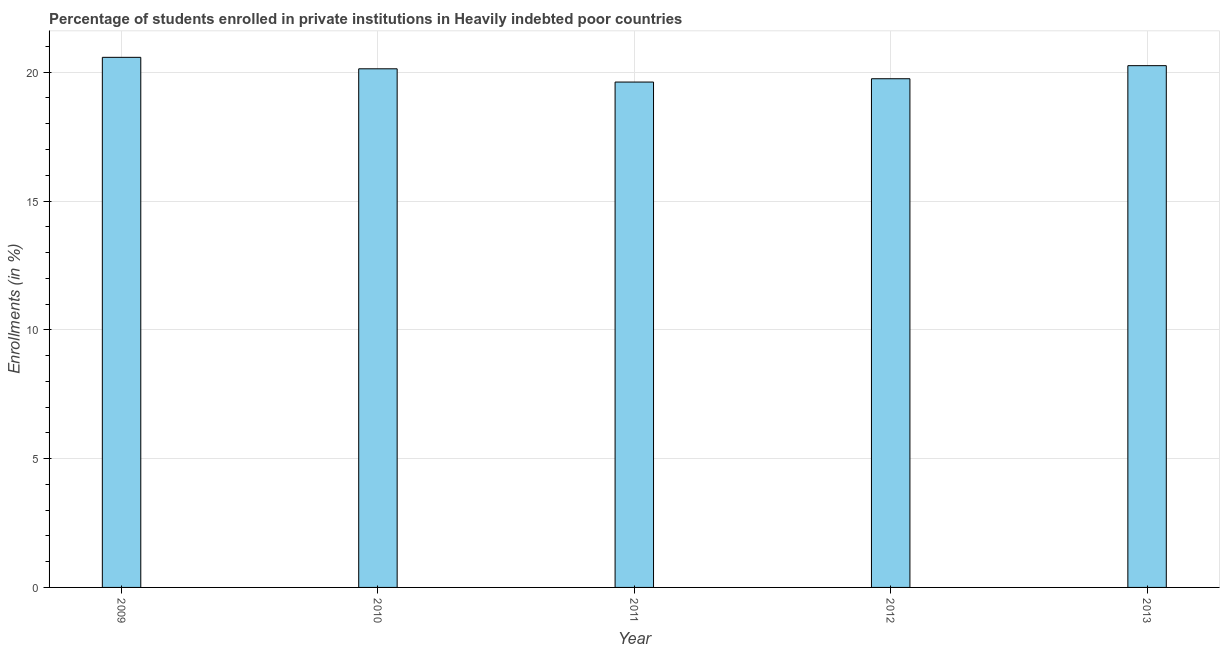Does the graph contain any zero values?
Ensure brevity in your answer.  No. Does the graph contain grids?
Provide a short and direct response. Yes. What is the title of the graph?
Give a very brief answer. Percentage of students enrolled in private institutions in Heavily indebted poor countries. What is the label or title of the Y-axis?
Ensure brevity in your answer.  Enrollments (in %). What is the enrollments in private institutions in 2009?
Offer a terse response. 20.58. Across all years, what is the maximum enrollments in private institutions?
Your answer should be compact. 20.58. Across all years, what is the minimum enrollments in private institutions?
Make the answer very short. 19.62. In which year was the enrollments in private institutions maximum?
Your response must be concise. 2009. In which year was the enrollments in private institutions minimum?
Ensure brevity in your answer.  2011. What is the sum of the enrollments in private institutions?
Your answer should be very brief. 100.33. What is the difference between the enrollments in private institutions in 2011 and 2013?
Make the answer very short. -0.64. What is the average enrollments in private institutions per year?
Give a very brief answer. 20.07. What is the median enrollments in private institutions?
Give a very brief answer. 20.13. Do a majority of the years between 2010 and 2013 (inclusive) have enrollments in private institutions greater than 10 %?
Your response must be concise. Yes. Is the difference between the enrollments in private institutions in 2009 and 2010 greater than the difference between any two years?
Offer a terse response. No. What is the difference between the highest and the second highest enrollments in private institutions?
Keep it short and to the point. 0.32. In how many years, is the enrollments in private institutions greater than the average enrollments in private institutions taken over all years?
Your answer should be compact. 3. How many bars are there?
Your response must be concise. 5. What is the Enrollments (in %) of 2009?
Make the answer very short. 20.58. What is the Enrollments (in %) in 2010?
Keep it short and to the point. 20.13. What is the Enrollments (in %) of 2011?
Give a very brief answer. 19.62. What is the Enrollments (in %) in 2012?
Your response must be concise. 19.75. What is the Enrollments (in %) in 2013?
Ensure brevity in your answer.  20.25. What is the difference between the Enrollments (in %) in 2009 and 2010?
Give a very brief answer. 0.45. What is the difference between the Enrollments (in %) in 2009 and 2011?
Your response must be concise. 0.96. What is the difference between the Enrollments (in %) in 2009 and 2012?
Your answer should be compact. 0.83. What is the difference between the Enrollments (in %) in 2009 and 2013?
Keep it short and to the point. 0.32. What is the difference between the Enrollments (in %) in 2010 and 2011?
Your answer should be very brief. 0.51. What is the difference between the Enrollments (in %) in 2010 and 2012?
Provide a short and direct response. 0.39. What is the difference between the Enrollments (in %) in 2010 and 2013?
Offer a terse response. -0.12. What is the difference between the Enrollments (in %) in 2011 and 2012?
Make the answer very short. -0.13. What is the difference between the Enrollments (in %) in 2011 and 2013?
Your answer should be very brief. -0.64. What is the difference between the Enrollments (in %) in 2012 and 2013?
Make the answer very short. -0.51. What is the ratio of the Enrollments (in %) in 2009 to that in 2010?
Offer a terse response. 1.02. What is the ratio of the Enrollments (in %) in 2009 to that in 2011?
Provide a succinct answer. 1.05. What is the ratio of the Enrollments (in %) in 2009 to that in 2012?
Ensure brevity in your answer.  1.04. What is the ratio of the Enrollments (in %) in 2009 to that in 2013?
Your response must be concise. 1.02. What is the ratio of the Enrollments (in %) in 2010 to that in 2011?
Ensure brevity in your answer.  1.03. What is the ratio of the Enrollments (in %) in 2010 to that in 2013?
Ensure brevity in your answer.  0.99. 